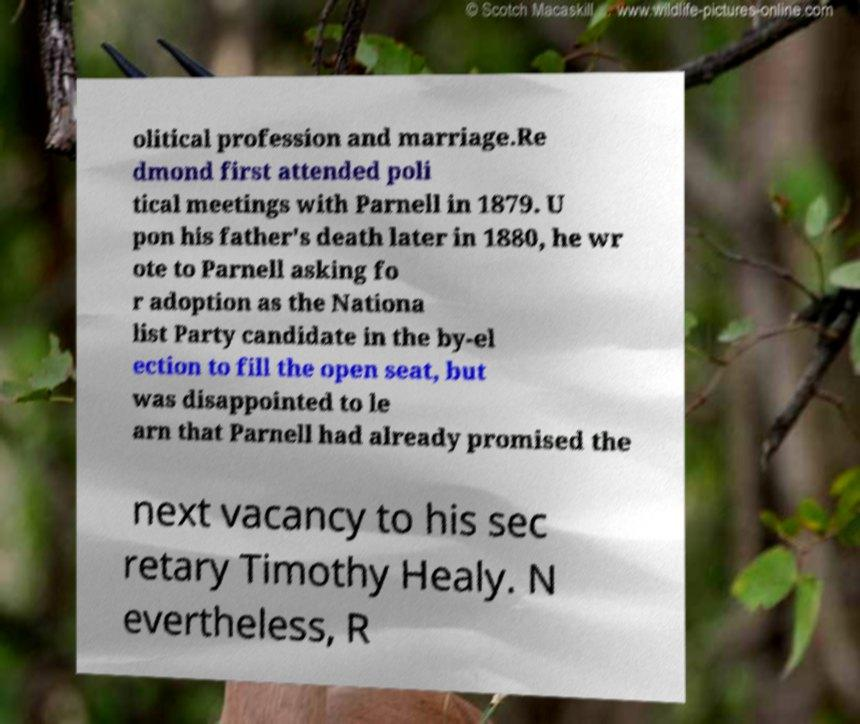Please identify and transcribe the text found in this image. olitical profession and marriage.Re dmond first attended poli tical meetings with Parnell in 1879. U pon his father's death later in 1880, he wr ote to Parnell asking fo r adoption as the Nationa list Party candidate in the by-el ection to fill the open seat, but was disappointed to le arn that Parnell had already promised the next vacancy to his sec retary Timothy Healy. N evertheless, R 